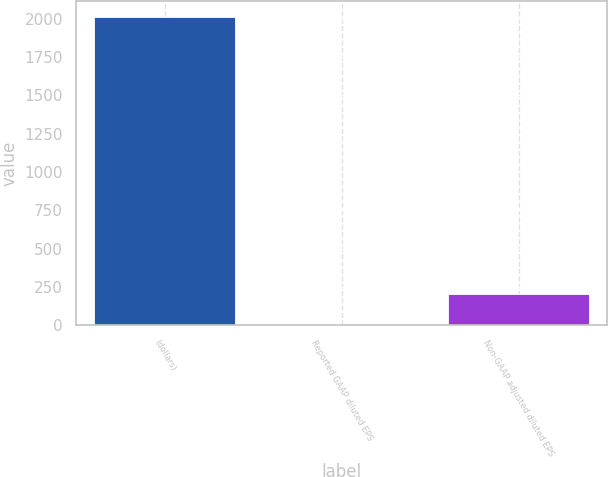Convert chart. <chart><loc_0><loc_0><loc_500><loc_500><bar_chart><fcel>(dollars)<fcel>Reported GAAP diluted EPS<fcel>Non-GAAP adjusted diluted EPS<nl><fcel>2015<fcel>3.32<fcel>204.49<nl></chart> 